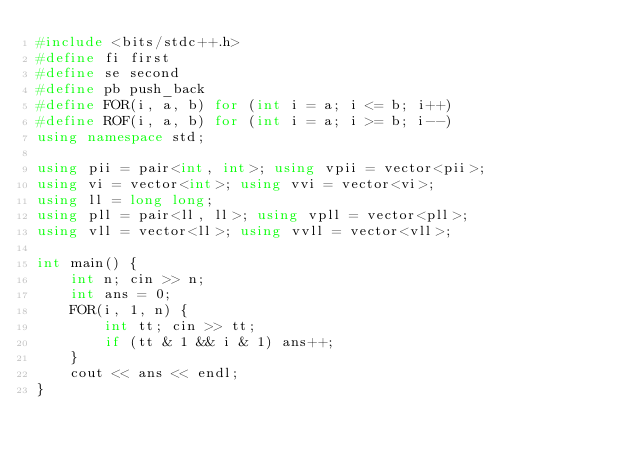<code> <loc_0><loc_0><loc_500><loc_500><_C++_>#include <bits/stdc++.h>
#define fi first
#define se second
#define pb push_back
#define FOR(i, a, b) for (int i = a; i <= b; i++)
#define ROF(i, a, b) for (int i = a; i >= b; i--)
using namespace std;

using pii = pair<int, int>; using vpii = vector<pii>;
using vi = vector<int>; using vvi = vector<vi>;
using ll = long long;
using pll = pair<ll, ll>; using vpll = vector<pll>;
using vll = vector<ll>; using vvll = vector<vll>;

int main() {
    int n; cin >> n;
    int ans = 0;
    FOR(i, 1, n) {
        int tt; cin >> tt;
        if (tt & 1 && i & 1) ans++;
    }
    cout << ans << endl;
}</code> 